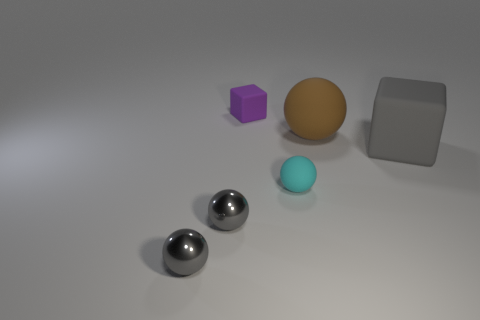There is a large ball that is made of the same material as the gray cube; what is its color?
Provide a short and direct response. Brown. What color is the thing that is behind the cyan matte ball and to the left of the brown rubber object?
Provide a succinct answer. Purple. What number of tiny cyan objects are right of the purple block?
Provide a short and direct response. 1. What number of objects are shiny objects or small objects that are behind the big sphere?
Give a very brief answer. 3. There is a tiny thing to the right of the tiny purple block; is there a brown rubber thing that is on the left side of it?
Your answer should be compact. No. What is the color of the ball behind the tiny cyan ball?
Ensure brevity in your answer.  Brown. Are there an equal number of cyan rubber spheres to the left of the small cyan matte sphere and small green shiny cylinders?
Your answer should be very brief. Yes. The object that is both behind the gray rubber thing and to the right of the cyan object has what shape?
Give a very brief answer. Sphere. There is another thing that is the same shape as the small purple rubber thing; what is its color?
Your answer should be very brief. Gray. Is there any other thing that has the same color as the large matte block?
Offer a very short reply. Yes. 